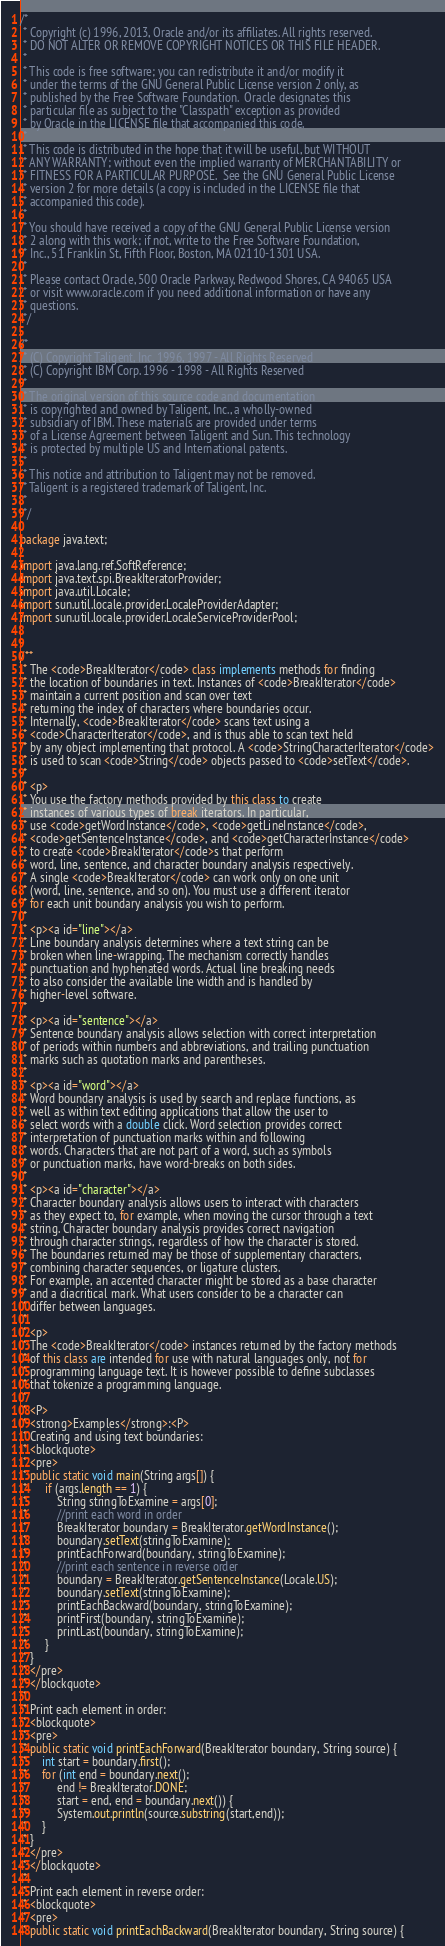<code> <loc_0><loc_0><loc_500><loc_500><_Java_>/*
 * Copyright (c) 1996, 2013, Oracle and/or its affiliates. All rights reserved.
 * DO NOT ALTER OR REMOVE COPYRIGHT NOTICES OR THIS FILE HEADER.
 *
 * This code is free software; you can redistribute it and/or modify it
 * under the terms of the GNU General Public License version 2 only, as
 * published by the Free Software Foundation.  Oracle designates this
 * particular file as subject to the "Classpath" exception as provided
 * by Oracle in the LICENSE file that accompanied this code.
 *
 * This code is distributed in the hope that it will be useful, but WITHOUT
 * ANY WARRANTY; without even the implied warranty of MERCHANTABILITY or
 * FITNESS FOR A PARTICULAR PURPOSE.  See the GNU General Public License
 * version 2 for more details (a copy is included in the LICENSE file that
 * accompanied this code).
 *
 * You should have received a copy of the GNU General Public License version
 * 2 along with this work; if not, write to the Free Software Foundation,
 * Inc., 51 Franklin St, Fifth Floor, Boston, MA 02110-1301 USA.
 *
 * Please contact Oracle, 500 Oracle Parkway, Redwood Shores, CA 94065 USA
 * or visit www.oracle.com if you need additional information or have any
 * questions.
 */

/*
 * (C) Copyright Taligent, Inc. 1996, 1997 - All Rights Reserved
 * (C) Copyright IBM Corp. 1996 - 1998 - All Rights Reserved
 *
 * The original version of this source code and documentation
 * is copyrighted and owned by Taligent, Inc., a wholly-owned
 * subsidiary of IBM. These materials are provided under terms
 * of a License Agreement between Taligent and Sun. This technology
 * is protected by multiple US and International patents.
 *
 * This notice and attribution to Taligent may not be removed.
 * Taligent is a registered trademark of Taligent, Inc.
 *
 */

package java.text;

import java.lang.ref.SoftReference;
import java.text.spi.BreakIteratorProvider;
import java.util.Locale;
import sun.util.locale.provider.LocaleProviderAdapter;
import sun.util.locale.provider.LocaleServiceProviderPool;


/**
 * The <code>BreakIterator</code> class implements methods for finding
 * the location of boundaries in text. Instances of <code>BreakIterator</code>
 * maintain a current position and scan over text
 * returning the index of characters where boundaries occur.
 * Internally, <code>BreakIterator</code> scans text using a
 * <code>CharacterIterator</code>, and is thus able to scan text held
 * by any object implementing that protocol. A <code>StringCharacterIterator</code>
 * is used to scan <code>String</code> objects passed to <code>setText</code>.
 *
 * <p>
 * You use the factory methods provided by this class to create
 * instances of various types of break iterators. In particular,
 * use <code>getWordInstance</code>, <code>getLineInstance</code>,
 * <code>getSentenceInstance</code>, and <code>getCharacterInstance</code>
 * to create <code>BreakIterator</code>s that perform
 * word, line, sentence, and character boundary analysis respectively.
 * A single <code>BreakIterator</code> can work only on one unit
 * (word, line, sentence, and so on). You must use a different iterator
 * for each unit boundary analysis you wish to perform.
 *
 * <p><a id="line"></a>
 * Line boundary analysis determines where a text string can be
 * broken when line-wrapping. The mechanism correctly handles
 * punctuation and hyphenated words. Actual line breaking needs
 * to also consider the available line width and is handled by
 * higher-level software.
 *
 * <p><a id="sentence"></a>
 * Sentence boundary analysis allows selection with correct interpretation
 * of periods within numbers and abbreviations, and trailing punctuation
 * marks such as quotation marks and parentheses.
 *
 * <p><a id="word"></a>
 * Word boundary analysis is used by search and replace functions, as
 * well as within text editing applications that allow the user to
 * select words with a double click. Word selection provides correct
 * interpretation of punctuation marks within and following
 * words. Characters that are not part of a word, such as symbols
 * or punctuation marks, have word-breaks on both sides.
 *
 * <p><a id="character"></a>
 * Character boundary analysis allows users to interact with characters
 * as they expect to, for example, when moving the cursor through a text
 * string. Character boundary analysis provides correct navigation
 * through character strings, regardless of how the character is stored.
 * The boundaries returned may be those of supplementary characters,
 * combining character sequences, or ligature clusters.
 * For example, an accented character might be stored as a base character
 * and a diacritical mark. What users consider to be a character can
 * differ between languages.
 *
 * <p>
 * The <code>BreakIterator</code> instances returned by the factory methods
 * of this class are intended for use with natural languages only, not for
 * programming language text. It is however possible to define subclasses
 * that tokenize a programming language.
 *
 * <P>
 * <strong>Examples</strong>:<P>
 * Creating and using text boundaries:
 * <blockquote>
 * <pre>
 * public static void main(String args[]) {
 *      if (args.length == 1) {
 *          String stringToExamine = args[0];
 *          //print each word in order
 *          BreakIterator boundary = BreakIterator.getWordInstance();
 *          boundary.setText(stringToExamine);
 *          printEachForward(boundary, stringToExamine);
 *          //print each sentence in reverse order
 *          boundary = BreakIterator.getSentenceInstance(Locale.US);
 *          boundary.setText(stringToExamine);
 *          printEachBackward(boundary, stringToExamine);
 *          printFirst(boundary, stringToExamine);
 *          printLast(boundary, stringToExamine);
 *      }
 * }
 * </pre>
 * </blockquote>
 *
 * Print each element in order:
 * <blockquote>
 * <pre>
 * public static void printEachForward(BreakIterator boundary, String source) {
 *     int start = boundary.first();
 *     for (int end = boundary.next();
 *          end != BreakIterator.DONE;
 *          start = end, end = boundary.next()) {
 *          System.out.println(source.substring(start,end));
 *     }
 * }
 * </pre>
 * </blockquote>
 *
 * Print each element in reverse order:
 * <blockquote>
 * <pre>
 * public static void printEachBackward(BreakIterator boundary, String source) {</code> 